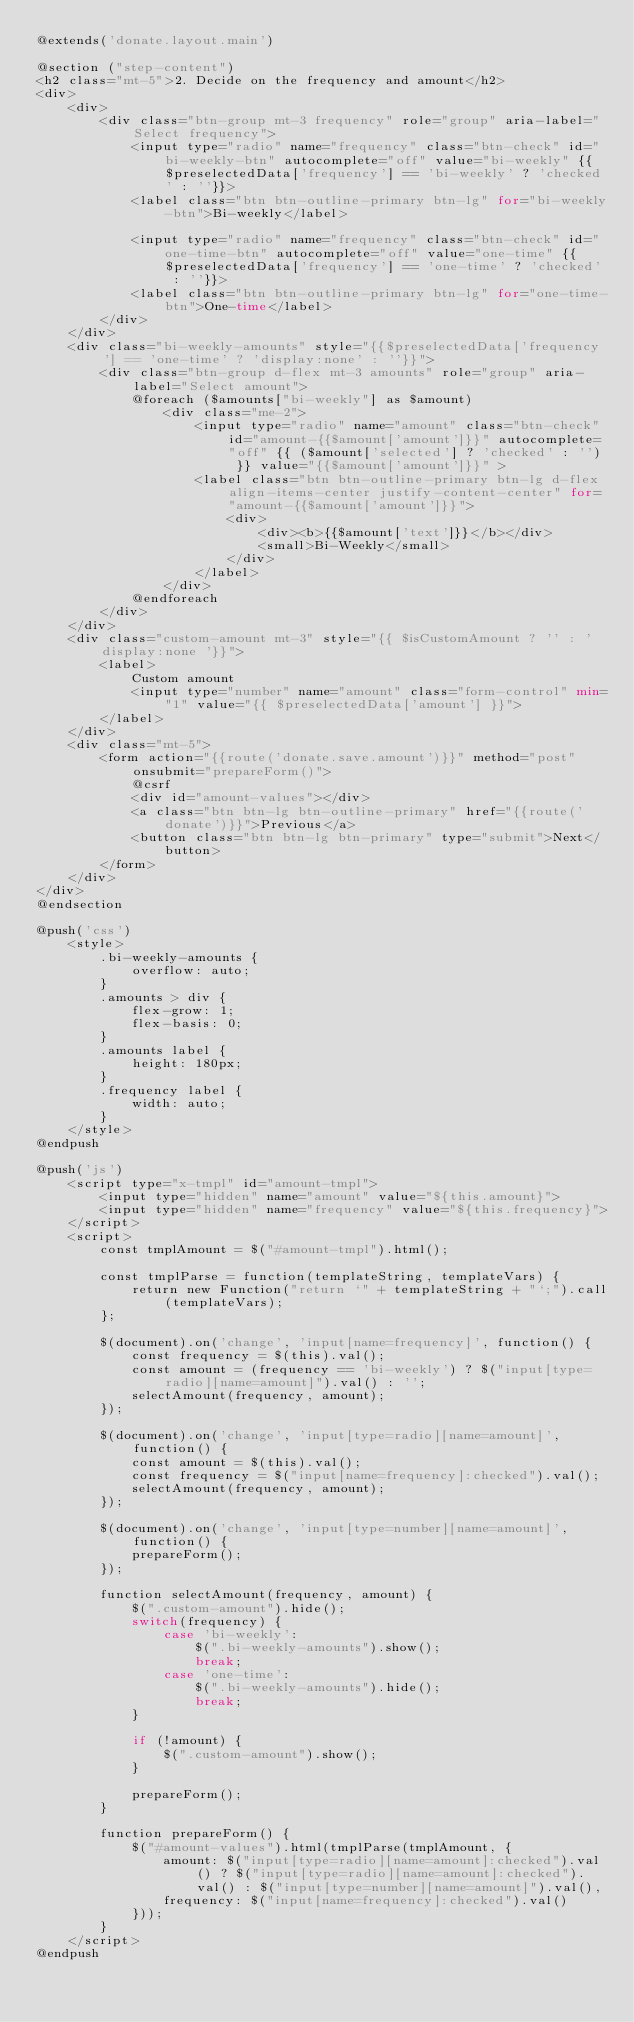<code> <loc_0><loc_0><loc_500><loc_500><_PHP_>@extends('donate.layout.main')

@section ("step-content")
<h2 class="mt-5">2. Decide on the frequency and amount</h2>
<div>
    <div>
        <div class="btn-group mt-3 frequency" role="group" aria-label="Select frequency">
            <input type="radio" name="frequency" class="btn-check" id="bi-weekly-btn" autocomplete="off" value="bi-weekly" {{$preselectedData['frequency'] == 'bi-weekly' ? 'checked' : ''}}>
            <label class="btn btn-outline-primary btn-lg" for="bi-weekly-btn">Bi-weekly</label>

            <input type="radio" name="frequency" class="btn-check" id="one-time-btn" autocomplete="off" value="one-time" {{$preselectedData['frequency'] == 'one-time' ? 'checked' : ''}}>
            <label class="btn btn-outline-primary btn-lg" for="one-time-btn">One-time</label>
        </div>
    </div>
    <div class="bi-weekly-amounts" style="{{$preselectedData['frequency'] == 'one-time' ? 'display:none' : ''}}">
        <div class="btn-group d-flex mt-3 amounts" role="group" aria-label="Select amount">
            @foreach ($amounts["bi-weekly"] as $amount)
                <div class="me-2">
                    <input type="radio" name="amount" class="btn-check" id="amount-{{$amount['amount']}}" autocomplete="off" {{ ($amount['selected'] ? 'checked' : '') }} value="{{$amount['amount']}}" >
                    <label class="btn btn-outline-primary btn-lg d-flex align-items-center justify-content-center" for="amount-{{$amount['amount']}}">
                        <div>
                            <div><b>{{$amount['text']}}</b></div>
                            <small>Bi-Weekly</small>
                        </div>
                    </label>
                </div>
            @endforeach
        </div>
    </div>
    <div class="custom-amount mt-3" style="{{ $isCustomAmount ? '' : 'display:none '}}">
        <label>
            Custom amount
            <input type="number" name="amount" class="form-control" min="1" value="{{ $preselectedData['amount'] }}">
        </label>
    </div>
    <div class="mt-5">
        <form action="{{route('donate.save.amount')}}" method="post" onsubmit="prepareForm()">
            @csrf
            <div id="amount-values"></div>
            <a class="btn btn-lg btn-outline-primary" href="{{route('donate')}}">Previous</a>
            <button class="btn btn-lg btn-primary" type="submit">Next</button>
        </form>
    </div>
</div>
@endsection 

@push('css')
    <style>
        .bi-weekly-amounts {
            overflow: auto;
        }
        .amounts > div {
            flex-grow: 1;
            flex-basis: 0;
        }
        .amounts label {
            height: 180px;
        }
        .frequency label {
            width: auto;
        }
    </style>
@endpush

@push('js')
    <script type="x-tmpl" id="amount-tmpl">
        <input type="hidden" name="amount" value="${this.amount}">
        <input type="hidden" name="frequency" value="${this.frequency}">
    </script>
    <script>
        const tmplAmount = $("#amount-tmpl").html();

        const tmplParse = function(templateString, templateVars) {
            return new Function("return `" + templateString + "`;").call(templateVars);
        };

        $(document).on('change', 'input[name=frequency]', function() {
            const frequency = $(this).val();
            const amount = (frequency == 'bi-weekly') ? $("input[type=radio][name=amount]").val() : '';
            selectAmount(frequency, amount);
        });

        $(document).on('change', 'input[type=radio][name=amount]', function() {
            const amount = $(this).val();
            const frequency = $("input[name=frequency]:checked").val();
            selectAmount(frequency, amount);
        });

        $(document).on('change', 'input[type=number][name=amount]', function() {
            prepareForm();
        });

        function selectAmount(frequency, amount) {
            $(".custom-amount").hide();
            switch(frequency) {
                case 'bi-weekly': 
                    $(".bi-weekly-amounts").show();
                    break;
                case 'one-time':
                    $(".bi-weekly-amounts").hide();
                    break;
            }

            if (!amount) {
                $(".custom-amount").show();
            }

            prepareForm();
        }

        function prepareForm() {
            $("#amount-values").html(tmplParse(tmplAmount, {
                amount: $("input[type=radio][name=amount]:checked").val() ? $("input[type=radio][name=amount]:checked").val() : $("input[type=number][name=amount]").val(),
                frequency: $("input[name=frequency]:checked").val()
            }));
        }
    </script>
@endpush
</code> 